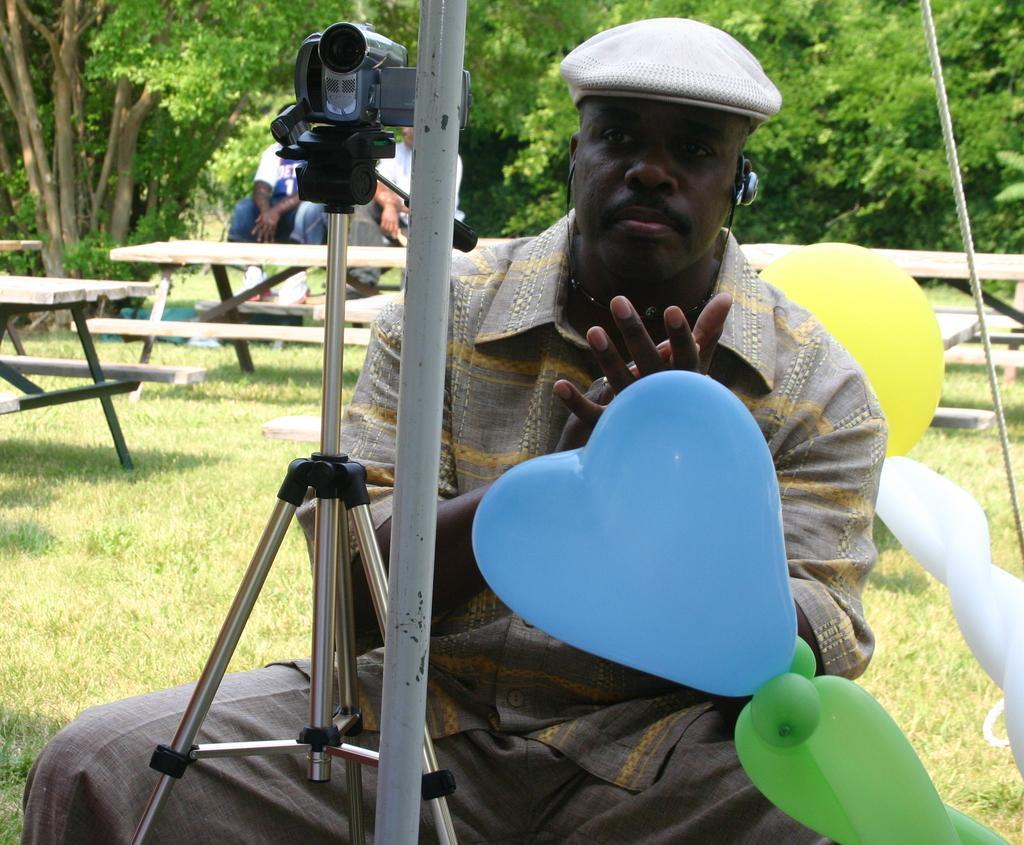Could you give a brief overview of what you see in this image? In this image, In the middle there is a man sitting and there is a camera stand and there is a camera in black color, There are some balloons in blue and yellow color, In the back ground there are some plants and trees in green color, There are some table which are brown color. 